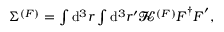<formula> <loc_0><loc_0><loc_500><loc_500>\begin{array} { r } { \Sigma ^ { ( F ) } = \int d ^ { 3 } { r } \int d ^ { 3 } { r } ^ { \prime } \mathbf s c r { K } ^ { ( F ) } F ^ { \dagger } F ^ { \prime } , } \end{array}</formula> 